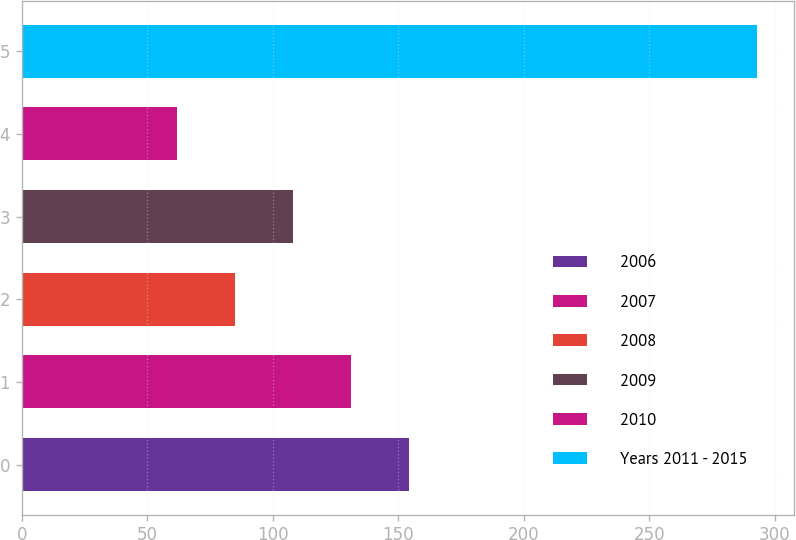Convert chart to OTSL. <chart><loc_0><loc_0><loc_500><loc_500><bar_chart><fcel>2006<fcel>2007<fcel>2008<fcel>2009<fcel>2010<fcel>Years 2011 - 2015<nl><fcel>154.4<fcel>131.3<fcel>85.1<fcel>108.2<fcel>62<fcel>293<nl></chart> 